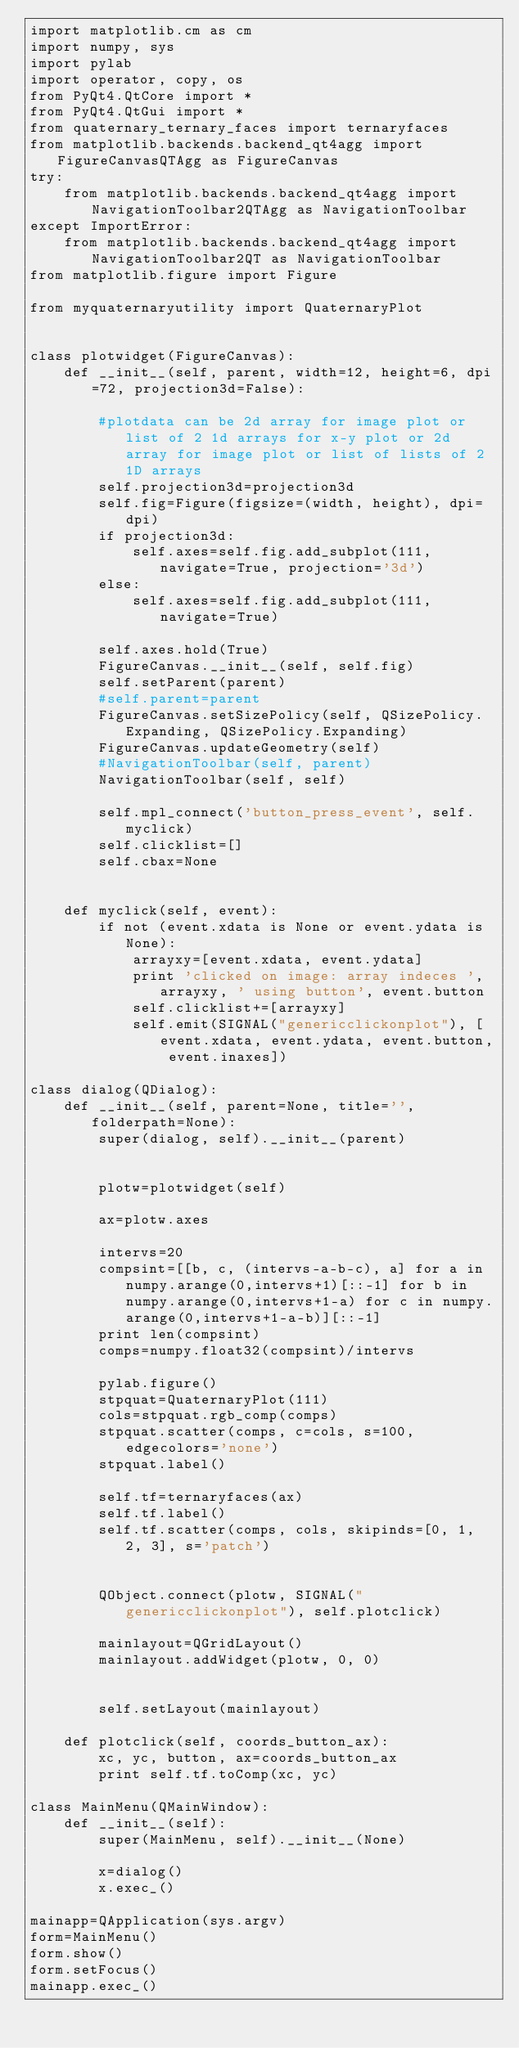<code> <loc_0><loc_0><loc_500><loc_500><_Python_>import matplotlib.cm as cm
import numpy, sys
import pylab
import operator, copy, os
from PyQt4.QtCore import *
from PyQt4.QtGui import *
from quaternary_ternary_faces import ternaryfaces
from matplotlib.backends.backend_qt4agg import FigureCanvasQTAgg as FigureCanvas
try:
    from matplotlib.backends.backend_qt4agg import NavigationToolbar2QTAgg as NavigationToolbar
except ImportError:
    from matplotlib.backends.backend_qt4agg import NavigationToolbar2QT as NavigationToolbar
from matplotlib.figure import Figure

from myquaternaryutility import QuaternaryPlot


class plotwidget(FigureCanvas):
    def __init__(self, parent, width=12, height=6, dpi=72, projection3d=False):

        #plotdata can be 2d array for image plot or list of 2 1d arrays for x-y plot or 2d array for image plot or list of lists of 2 1D arrays
        self.projection3d=projection3d
        self.fig=Figure(figsize=(width, height), dpi=dpi)
        if projection3d:
            self.axes=self.fig.add_subplot(111, navigate=True, projection='3d')
        else:
            self.axes=self.fig.add_subplot(111, navigate=True)

        self.axes.hold(True)
        FigureCanvas.__init__(self, self.fig)
        self.setParent(parent)
        #self.parent=parent
        FigureCanvas.setSizePolicy(self, QSizePolicy.Expanding, QSizePolicy.Expanding)
        FigureCanvas.updateGeometry(self)
        #NavigationToolbar(self, parent)
        NavigationToolbar(self, self)

        self.mpl_connect('button_press_event', self.myclick)
        self.clicklist=[]
        self.cbax=None
    

    def myclick(self, event):
        if not (event.xdata is None or event.ydata is None):
            arrayxy=[event.xdata, event.ydata]
            print 'clicked on image: array indeces ', arrayxy, ' using button', event.button
            self.clicklist+=[arrayxy]
            self.emit(SIGNAL("genericclickonplot"), [event.xdata, event.ydata, event.button, event.inaxes])

class dialog(QDialog):
    def __init__(self, parent=None, title='', folderpath=None):
        super(dialog, self).__init__(parent)

        
        plotw=plotwidget(self)
        
        ax=plotw.axes
        
        intervs=20
        compsint=[[b, c, (intervs-a-b-c), a] for a in numpy.arange(0,intervs+1)[::-1] for b in numpy.arange(0,intervs+1-a) for c in numpy.arange(0,intervs+1-a-b)][::-1]
        print len(compsint)
        comps=numpy.float32(compsint)/intervs

        pylab.figure()
        stpquat=QuaternaryPlot(111)
        cols=stpquat.rgb_comp(comps)
        stpquat.scatter(comps, c=cols, s=100, edgecolors='none')
        stpquat.label()

        self.tf=ternaryfaces(ax)
        self.tf.label()
        self.tf.scatter(comps, cols, skipinds=[0, 1, 2, 3], s='patch')
        
        
        QObject.connect(plotw, SIGNAL("genericclickonplot"), self.plotclick)
        
        mainlayout=QGridLayout()
        mainlayout.addWidget(plotw, 0, 0)

        
        self.setLayout(mainlayout)
    
    def plotclick(self, coords_button_ax):
        xc, yc, button, ax=coords_button_ax
        print self.tf.toComp(xc, yc)
        
class MainMenu(QMainWindow):
    def __init__(self):
        super(MainMenu, self).__init__(None)
        
        x=dialog()
        x.exec_()
        
mainapp=QApplication(sys.argv)
form=MainMenu()
form.show()
form.setFocus()
mainapp.exec_()

</code> 